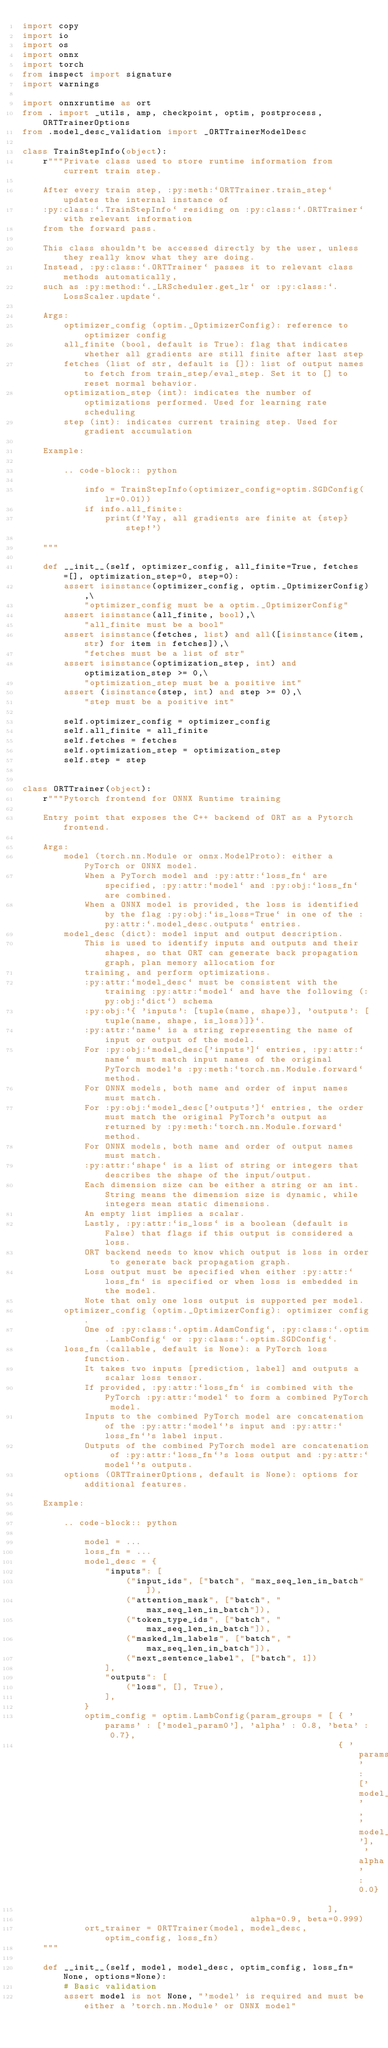Convert code to text. <code><loc_0><loc_0><loc_500><loc_500><_Python_>import copy
import io
import os
import onnx
import torch
from inspect import signature
import warnings

import onnxruntime as ort
from . import _utils, amp, checkpoint, optim, postprocess, ORTTrainerOptions
from .model_desc_validation import _ORTTrainerModelDesc

class TrainStepInfo(object):
    r"""Private class used to store runtime information from current train step.

    After every train step, :py:meth:`ORTTrainer.train_step` updates the internal instance of
    :py:class:`.TrainStepInfo` residing on :py:class:`.ORTTrainer` with relevant information
    from the forward pass.

    This class shouldn't be accessed directly by the user, unless they really know what they are doing.
    Instead, :py:class:`.ORTTrainer` passes it to relevant class methods automatically,
    such as :py:method:`._LRScheduler.get_lr` or :py:class:`.LossScaler.update`.

    Args:
        optimizer_config (optim._OptimizerConfig): reference to optimizer config
        all_finite (bool, default is True): flag that indicates whether all gradients are still finite after last step
        fetches (list of str, default is []): list of output names to fetch from train_step/eval_step. Set it to [] to reset normal behavior.
        optimization_step (int): indicates the number of optimizations performed. Used for learning rate scheduling
        step (int): indicates current training step. Used for gradient accumulation

    Example:

        .. code-block:: python

            info = TrainStepInfo(optimizer_config=optim.SGDConfig(lr=0.01))
            if info.all_finite:
                print(f'Yay, all gradients are finite at {step} step!')

    """

    def __init__(self, optimizer_config, all_finite=True, fetches=[], optimization_step=0, step=0):
        assert isinstance(optimizer_config, optim._OptimizerConfig),\
            "optimizer_config must be a optim._OptimizerConfig"
        assert isinstance(all_finite, bool),\
            "all_finite must be a bool"
        assert isinstance(fetches, list) and all([isinstance(item, str) for item in fetches]),\
            "fetches must be a list of str"
        assert isinstance(optimization_step, int) and optimization_step >= 0,\
            "optimization_step must be a positive int"
        assert (isinstance(step, int) and step >= 0),\
            "step must be a positive int"

        self.optimizer_config = optimizer_config
        self.all_finite = all_finite
        self.fetches = fetches
        self.optimization_step = optimization_step
        self.step = step


class ORTTrainer(object):
    r"""Pytorch frontend for ONNX Runtime training

    Entry point that exposes the C++ backend of ORT as a Pytorch frontend.

    Args:
        model (torch.nn.Module or onnx.ModelProto): either a PyTorch or ONNX model.
            When a PyTorch model and :py:attr:`loss_fn` are specified, :py:attr:`model` and :py:obj:`loss_fn` are combined.
            When a ONNX model is provided, the loss is identified by the flag :py:obj:`is_loss=True` in one of the :py:attr:`.model_desc.outputs` entries.
        model_desc (dict): model input and output description.
            This is used to identify inputs and outputs and their shapes, so that ORT can generate back propagation graph, plan memory allocation for
            training, and perform optimizations.
            :py:attr:`model_desc` must be consistent with the training :py:attr:`model` and have the following (:py:obj:`dict`) schema
            :py:obj:`{ 'inputs': [tuple(name, shape)], 'outputs': [tuple(name, shape, is_loss)]}`.
            :py:attr:`name` is a string representing the name of input or output of the model.
            For :py:obj:`model_desc['inputs']` entries, :py:attr:`name` must match input names of the original PyTorch model's :py:meth:`torch.nn.Module.forward` method.
            For ONNX models, both name and order of input names must match.
            For :py:obj:`model_desc['outputs']` entries, the order must match the original PyTorch's output as returned by :py:meth:`torch.nn.Module.forward` method.
            For ONNX models, both name and order of output names must match.
            :py:attr:`shape` is a list of string or integers that describes the shape of the input/output.
            Each dimension size can be either a string or an int. String means the dimension size is dynamic, while integers mean static dimensions.
            An empty list implies a scalar.
            Lastly, :py:attr:`is_loss` is a boolean (default is False) that flags if this output is considered a loss.
            ORT backend needs to know which output is loss in order to generate back propagation graph.
            Loss output must be specified when either :py:attr:`loss_fn` is specified or when loss is embedded in the model.
            Note that only one loss output is supported per model.
        optimizer_config (optim._OptimizerConfig): optimizer config.
            One of :py:class:`.optim.AdamConfig`, :py:class:`.optim.LambConfig` or :py:class:`.optim.SGDConfig`.
        loss_fn (callable, default is None): a PyTorch loss function.
            It takes two inputs [prediction, label] and outputs a scalar loss tensor.
            If provided, :py:attr:`loss_fn` is combined with the PyTorch :py:attr:`model` to form a combined PyTorch model.
            Inputs to the combined PyTorch model are concatenation of the :py:attr:`model`'s input and :py:attr:`loss_fn`'s label input.
            Outputs of the combined PyTorch model are concatenation of :py:attr:`loss_fn`'s loss output and :py:attr:`model`'s outputs.
        options (ORTTrainerOptions, default is None): options for additional features.

    Example:

        .. code-block:: python

            model = ...
            loss_fn = ...
            model_desc = {
                "inputs": [
                    ("input_ids", ["batch", "max_seq_len_in_batch"]),
                    ("attention_mask", ["batch", "max_seq_len_in_batch"]),
                    ("token_type_ids", ["batch", "max_seq_len_in_batch"]),
                    ("masked_lm_labels", ["batch", "max_seq_len_in_batch"]),
                    ("next_sentence_label", ["batch", 1])
                ],
                "outputs": [
                    ("loss", [], True),
                ],
            }
            optim_config = optim.LambConfig(param_groups = [ { 'params' : ['model_param0'], 'alpha' : 0.8, 'beta' : 0.7},
                                                             { 'params' : ['model_param1' , 'model_param_2'], 'alpha' : 0.0}
                                                           ],
                                            alpha=0.9, beta=0.999)
            ort_trainer = ORTTrainer(model, model_desc, optim_config, loss_fn)
    """

    def __init__(self, model, model_desc, optim_config, loss_fn=None, options=None):
        # Basic validation
        assert model is not None, "'model' is required and must be either a 'torch.nn.Module' or ONNX model"</code> 